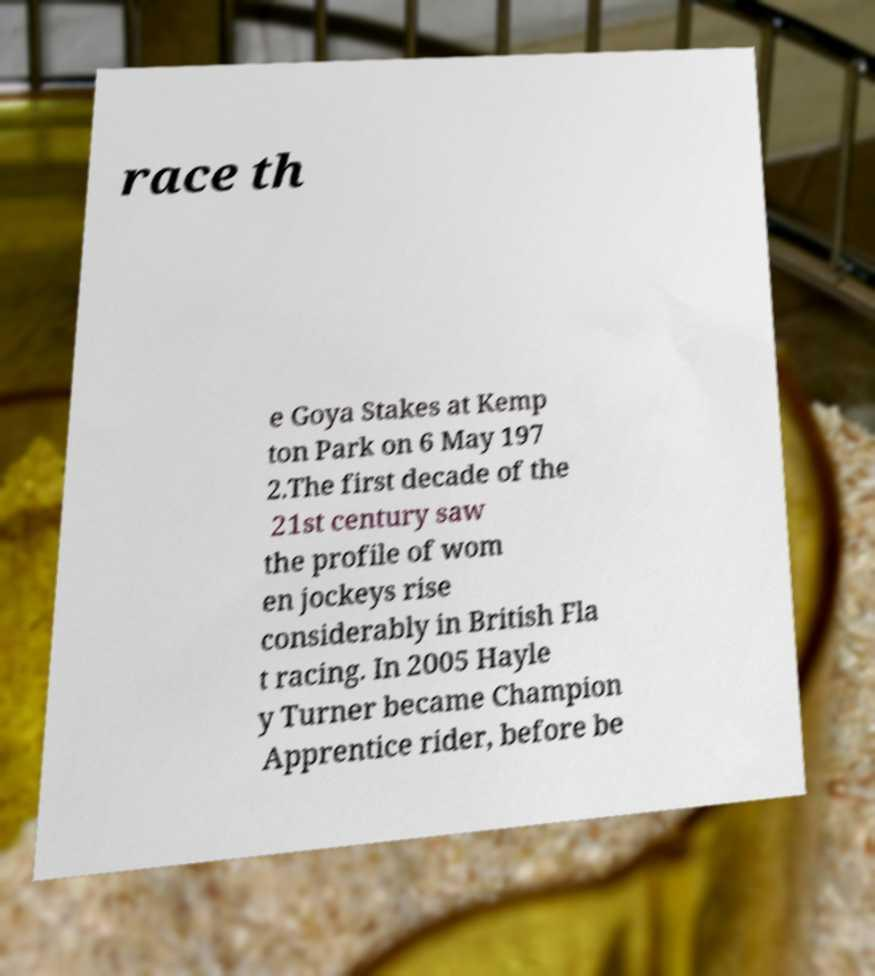Can you accurately transcribe the text from the provided image for me? race th e Goya Stakes at Kemp ton Park on 6 May 197 2.The first decade of the 21st century saw the profile of wom en jockeys rise considerably in British Fla t racing. In 2005 Hayle y Turner became Champion Apprentice rider, before be 